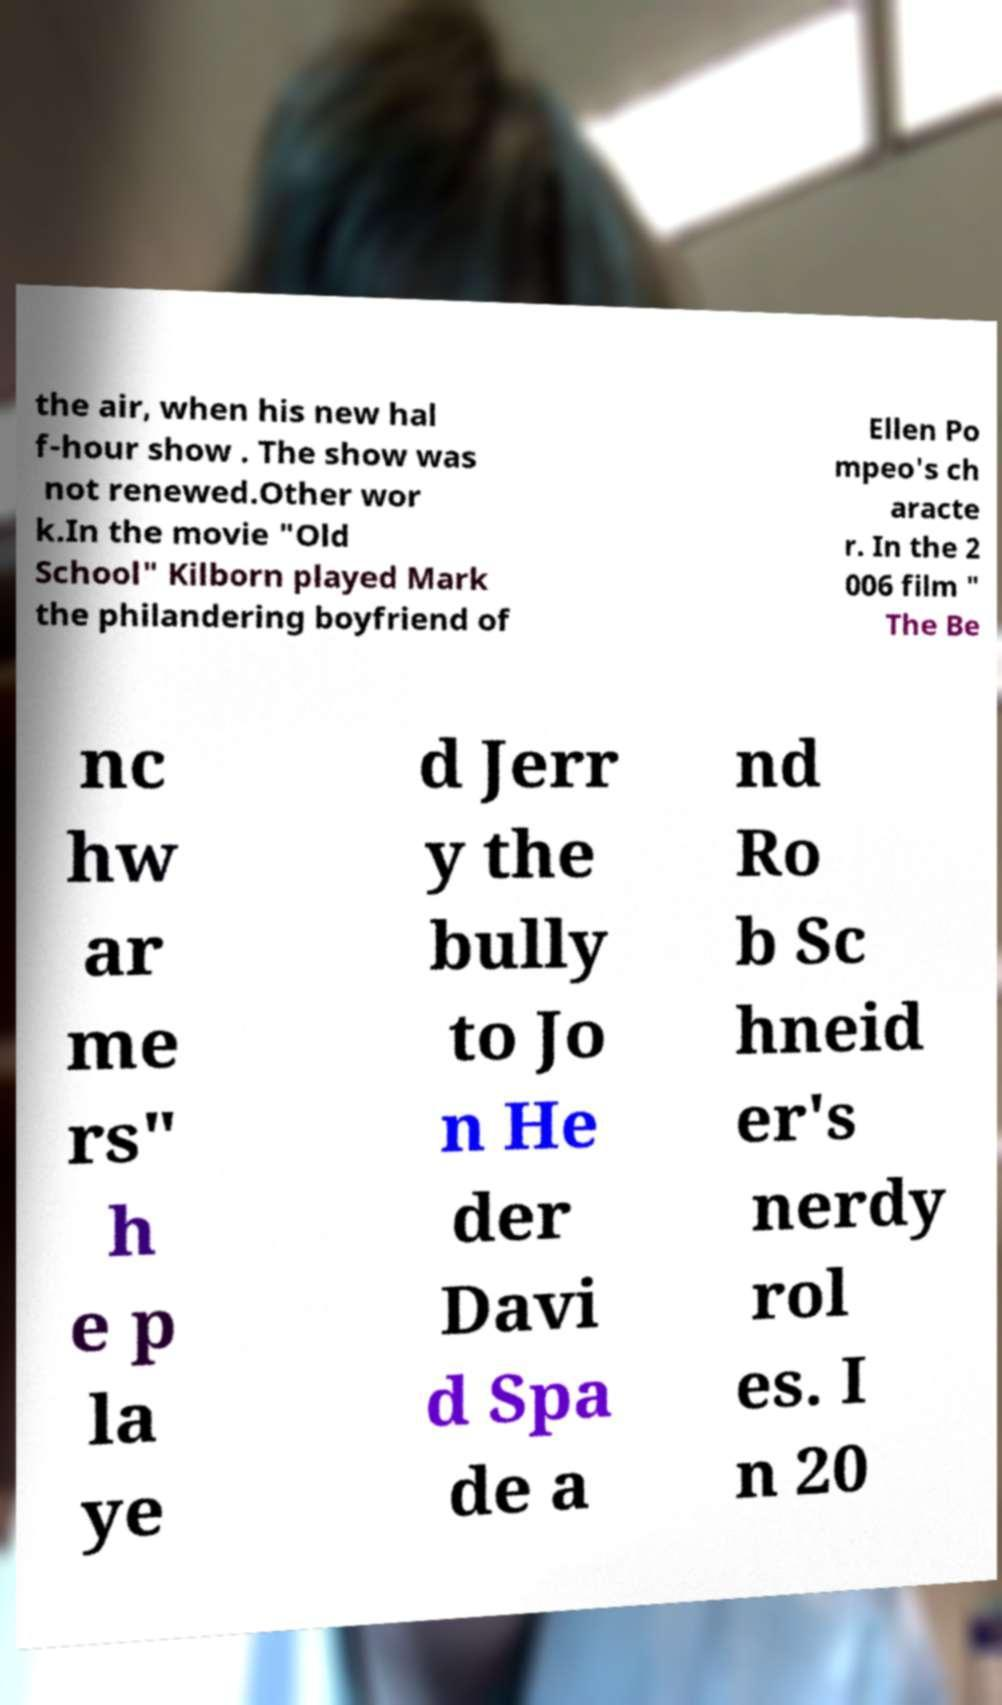For documentation purposes, I need the text within this image transcribed. Could you provide that? the air, when his new hal f-hour show . The show was not renewed.Other wor k.In the movie "Old School" Kilborn played Mark the philandering boyfriend of Ellen Po mpeo's ch aracte r. In the 2 006 film " The Be nc hw ar me rs" h e p la ye d Jerr y the bully to Jo n He der Davi d Spa de a nd Ro b Sc hneid er's nerdy rol es. I n 20 